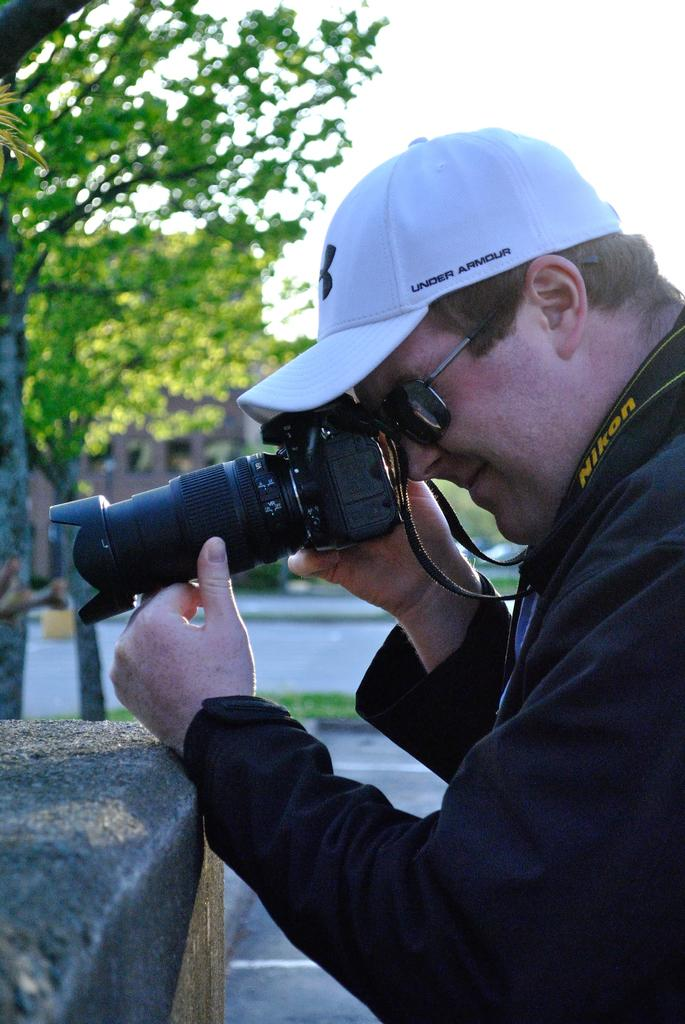What is the main subject of the image? The main subject of the image is a man. Can you describe the man's attire? The man is wearing a cap and shades. What is the man holding in the image? The man is holding a camera. What can be seen in the background of the image? There are trees, a path, and the sky visible in the background of the image. What is the purpose of the railway in the image? There is no railway present in the image. Can you tell me how many parents are visible in the image? There are no parents visible in the image; it features a man holding a camera. 